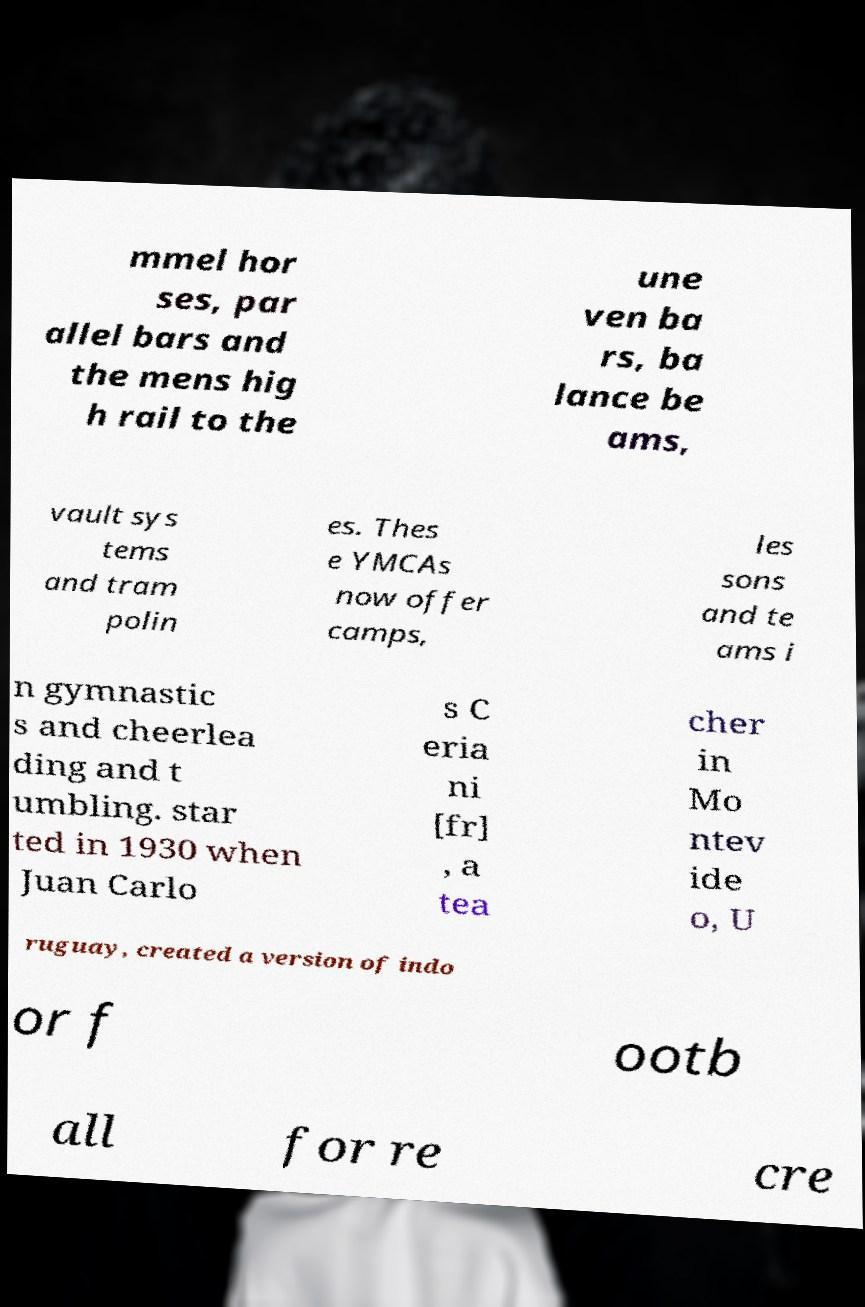Could you extract and type out the text from this image? mmel hor ses, par allel bars and the mens hig h rail to the une ven ba rs, ba lance be ams, vault sys tems and tram polin es. Thes e YMCAs now offer camps, les sons and te ams i n gymnastic s and cheerlea ding and t umbling. star ted in 1930 when Juan Carlo s C eria ni [fr] , a tea cher in Mo ntev ide o, U ruguay, created a version of indo or f ootb all for re cre 